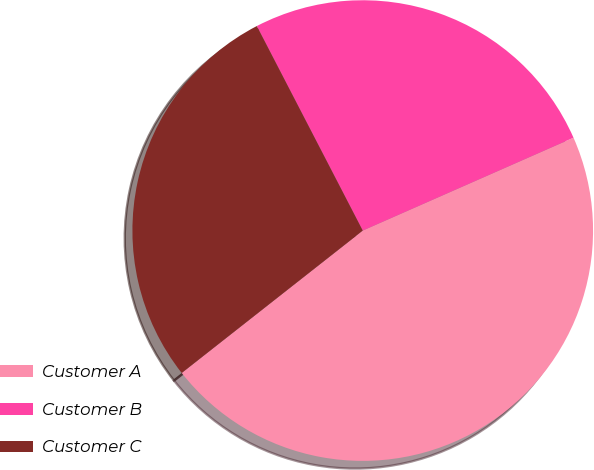<chart> <loc_0><loc_0><loc_500><loc_500><pie_chart><fcel>Customer A<fcel>Customer B<fcel>Customer C<nl><fcel>46.0%<fcel>26.0%<fcel>28.0%<nl></chart> 